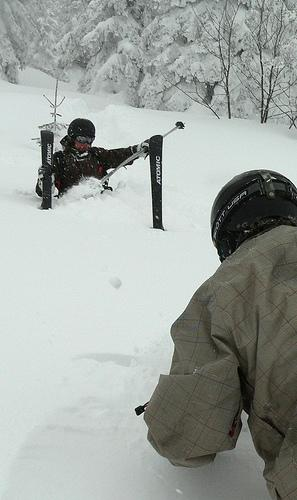How many person can be seen? two 